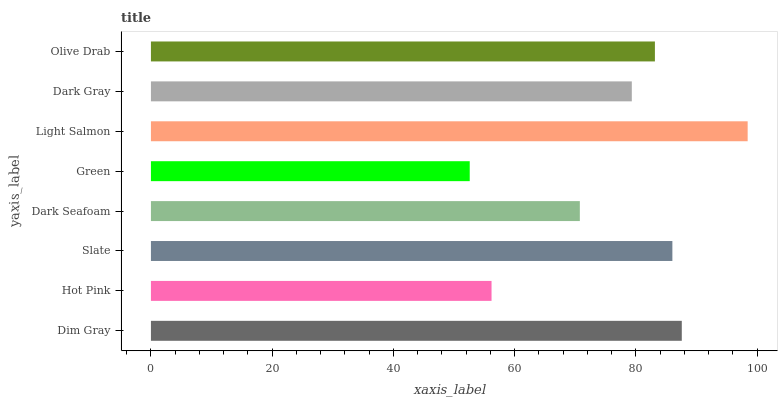Is Green the minimum?
Answer yes or no. Yes. Is Light Salmon the maximum?
Answer yes or no. Yes. Is Hot Pink the minimum?
Answer yes or no. No. Is Hot Pink the maximum?
Answer yes or no. No. Is Dim Gray greater than Hot Pink?
Answer yes or no. Yes. Is Hot Pink less than Dim Gray?
Answer yes or no. Yes. Is Hot Pink greater than Dim Gray?
Answer yes or no. No. Is Dim Gray less than Hot Pink?
Answer yes or no. No. Is Olive Drab the high median?
Answer yes or no. Yes. Is Dark Gray the low median?
Answer yes or no. Yes. Is Light Salmon the high median?
Answer yes or no. No. Is Dark Seafoam the low median?
Answer yes or no. No. 